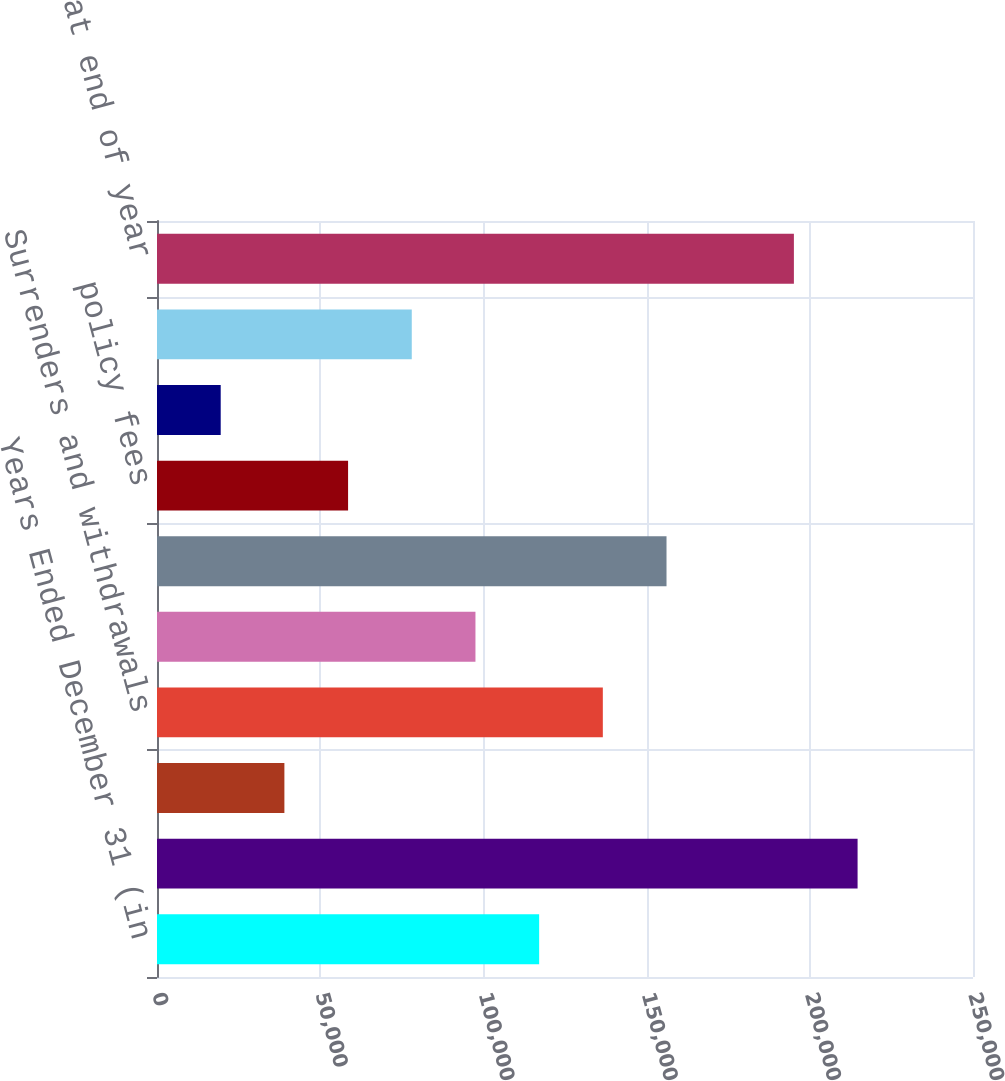Convert chart. <chart><loc_0><loc_0><loc_500><loc_500><bar_chart><fcel>Years Ended December 31 (in<fcel>Balance at beginning of year<fcel>Premiums and deposits<fcel>Surrenders and withdrawals<fcel>Death and other contract<fcel>Subtotal<fcel>policy fees<fcel>Cost of funds<fcel>Other reserve changes<fcel>Balance at end of year<nl><fcel>117078<fcel>214639<fcel>39029.4<fcel>136590<fcel>97566<fcel>156103<fcel>58541.6<fcel>19517.2<fcel>78053.8<fcel>195127<nl></chart> 